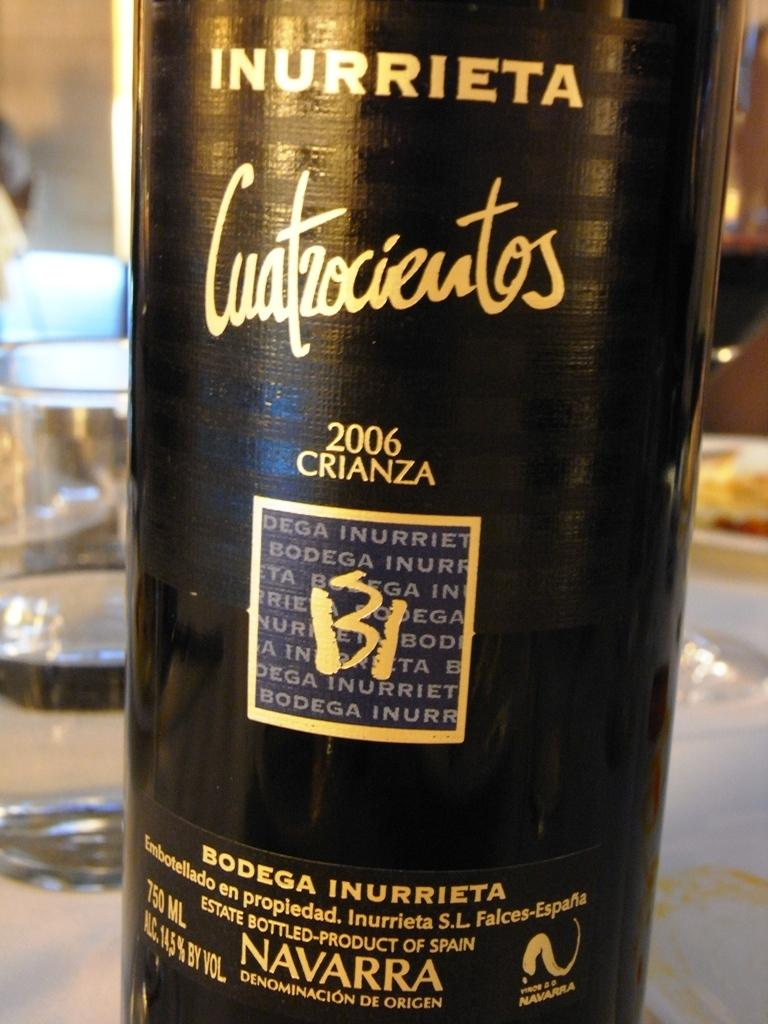<image>
Give a short and clear explanation of the subsequent image. A bottle of Inurrieta on a table with glasses and food. 